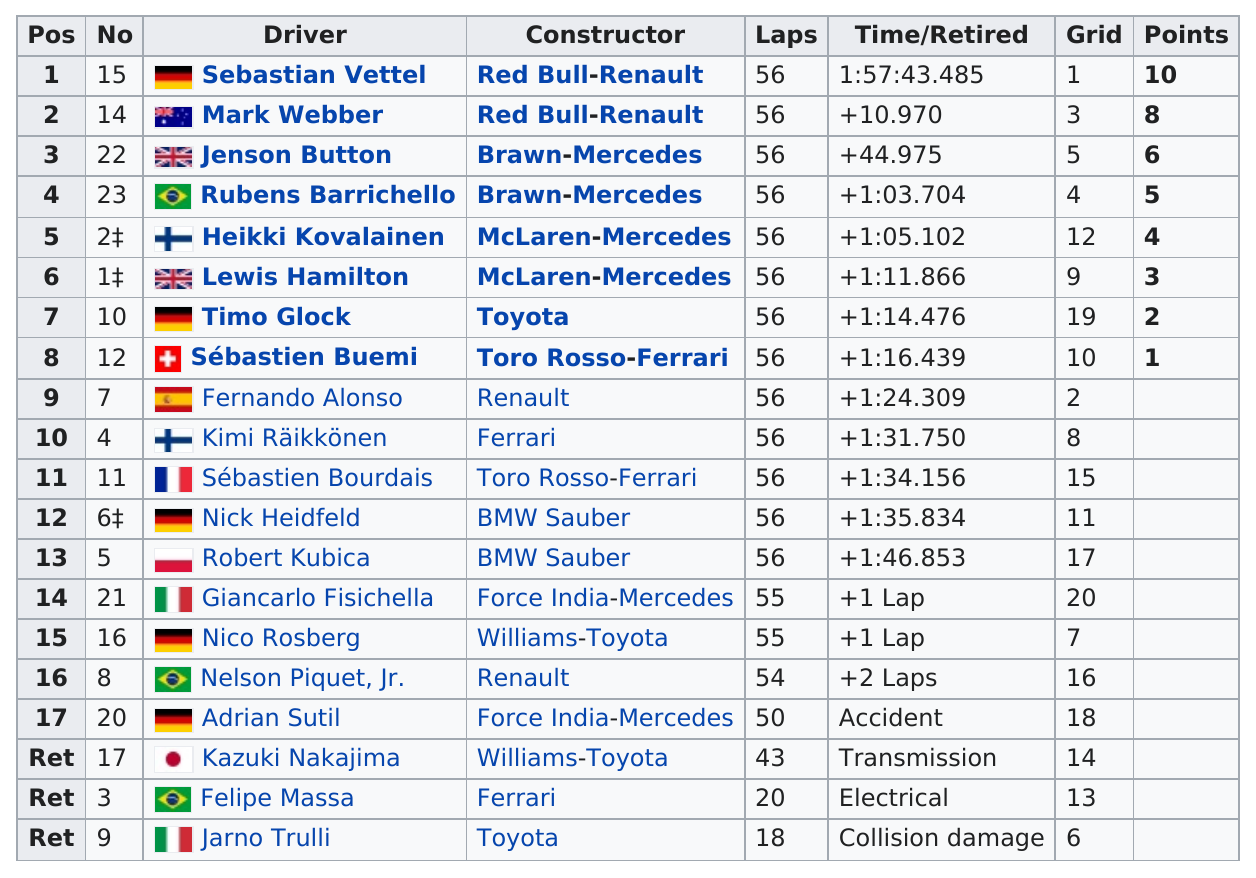Indicate a few pertinent items in this graphic. Ferrari, a constructor, did not have a driver named Sebastian Vettel, who was a driver for another entity. Sebastian Vettel was the first driver to complete the race. Jarno Trulli is the only driver who retired due to collision damage. Robert Kubica was the slowest driver to complete the race. Seventeen drivers completed at least 50 laps in the race. 